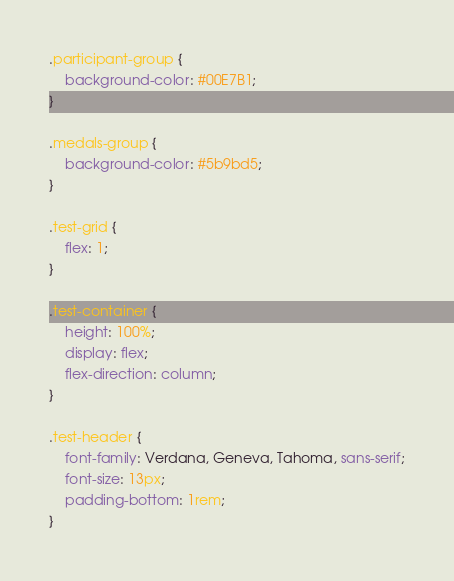<code> <loc_0><loc_0><loc_500><loc_500><_CSS_>.participant-group {
    background-color: #00E7B1;
}

.medals-group {
    background-color: #5b9bd5;
}

.test-grid {
    flex: 1;
}

.test-container {
    height: 100%;
    display: flex;
    flex-direction: column;
}

.test-header {
    font-family: Verdana, Geneva, Tahoma, sans-serif;
    font-size: 13px;
    padding-bottom: 1rem;
}
</code> 